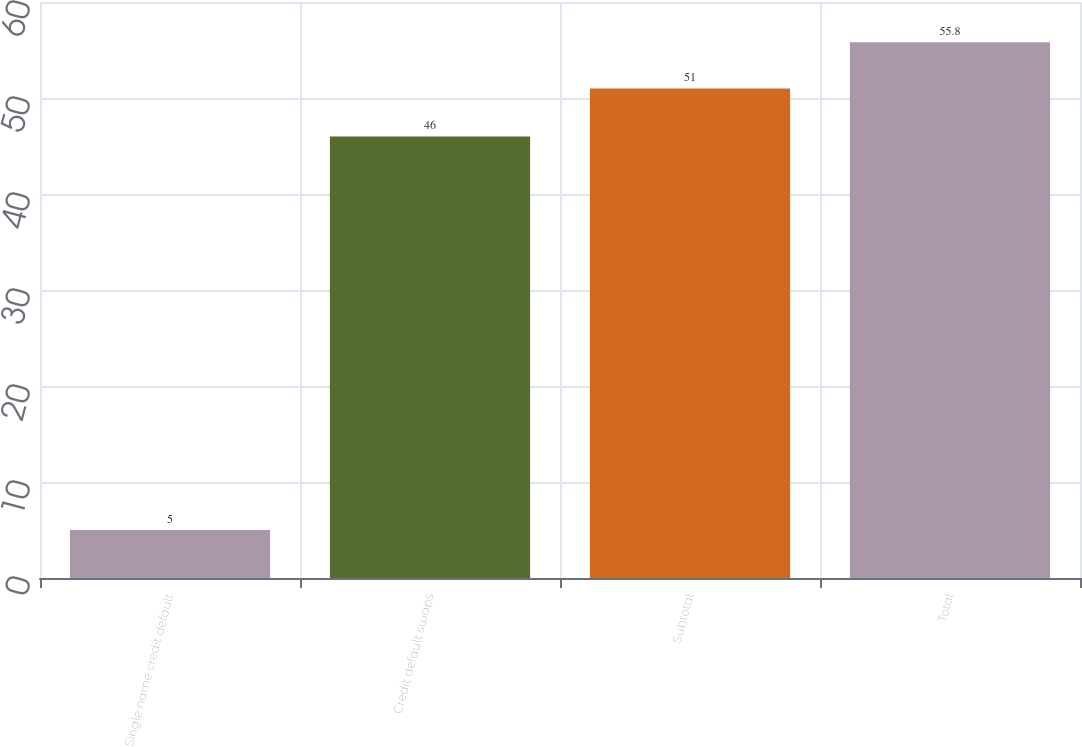Convert chart to OTSL. <chart><loc_0><loc_0><loc_500><loc_500><bar_chart><fcel>Single name credit default<fcel>Credit default swaps<fcel>Subtotal<fcel>Total<nl><fcel>5<fcel>46<fcel>51<fcel>55.8<nl></chart> 